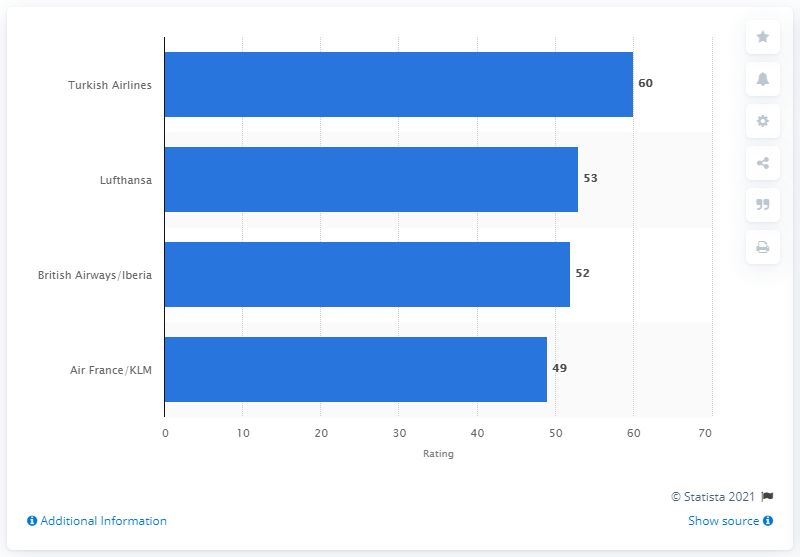Mention a couple of crucial points in this snapshot. According to the source, Turkish Airlines is the best airline for economy long-haul flights in Europe. In January 2015, the net score for Turkish Airlines' economy long-haul flights was 60. 